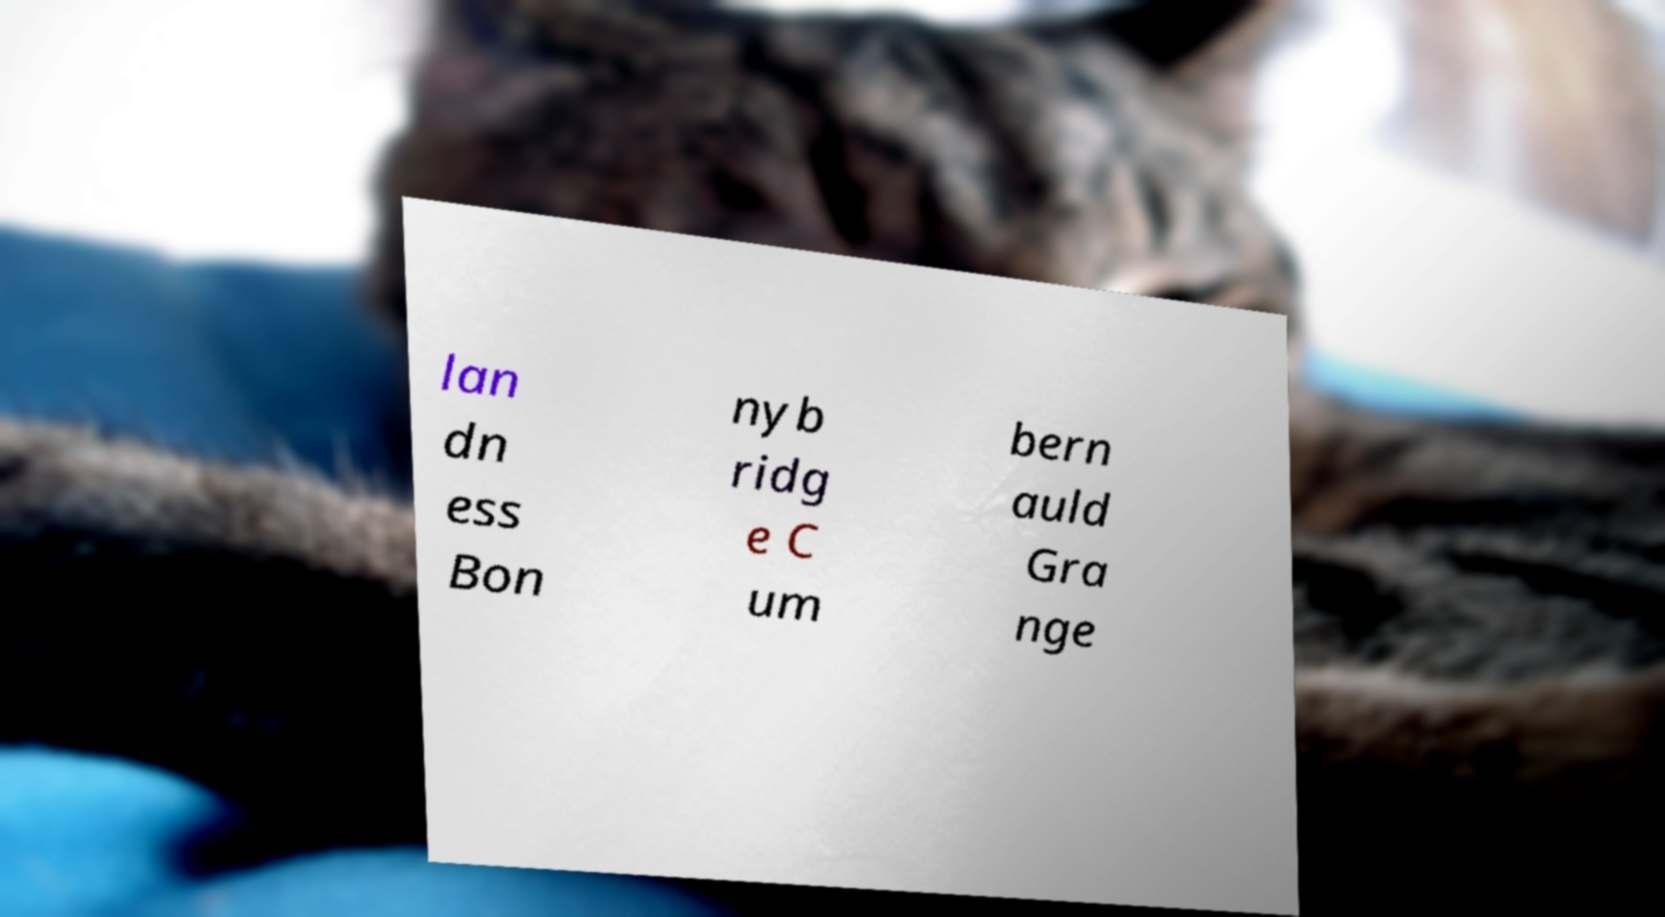For documentation purposes, I need the text within this image transcribed. Could you provide that? lan dn ess Bon nyb ridg e C um bern auld Gra nge 